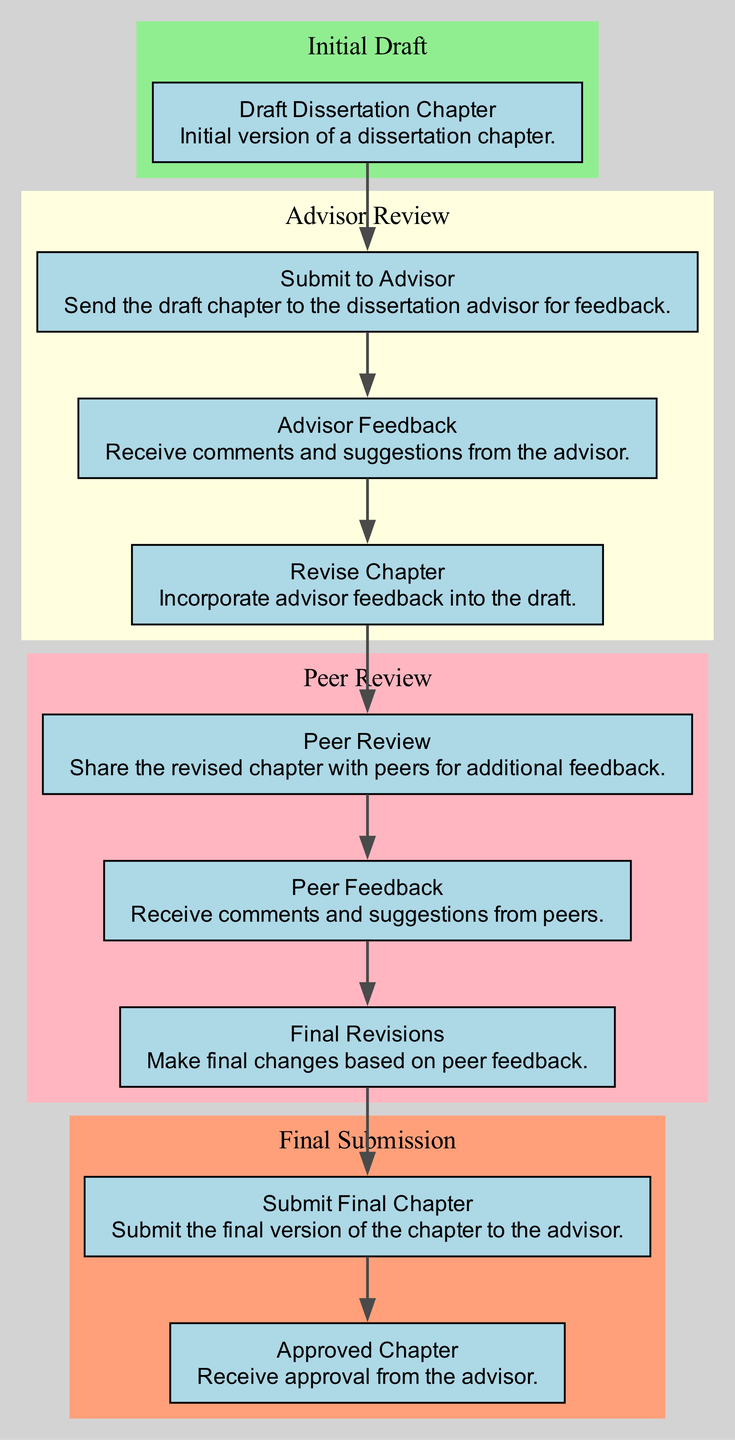What is the first step in the feedback loop? The first step in the feedback loop starts with the "Draft Dissertation Chapter", where the initial version is created.
Answer: Draft Dissertation Chapter How many sections are there in the flow chart? The flow chart is divided into four sections: Initial Draft, Advisor Review, Peer Review, and Final Submission.
Answer: Four What comes after "Submit to Advisor"? After submitting to the advisor, the next step is to receive "Advisor Feedback."
Answer: Advisor Feedback How many feedback sources are included in the process? The diagram shows two feedback sources: the advisor and peers.
Answer: Two What is the outcome after "Final Revisions"? The outcome after "Final Revisions" is to "Submit Final Chapter" to the advisor.
Answer: Submit Final Chapter Which node follows "Peer Review"? The node that follows "Peer Review" is "Peer Feedback".
Answer: Peer Feedback What actions are required after receiving "Peer Feedback"? After receiving "Peer Feedback", the necessary action is to make "Final Revisions".
Answer: Final Revisions What happens if the advisor does not approve the chapter? The feedback loop does not show an explicit path if the chapter is not approved; it implies revisions would be needed.
Answer: Revisions needed What is encapsulated within the "Peer Review" cluster? The "Peer Review" cluster encapsulates the nodes for "Peer Review," "Peer Feedback," and "Final Revisions."
Answer: Peer Review, Peer Feedback, Final Revisions Which node symbolizes the final step of the process? The final step of the process is symbolized by the node "Approved Chapter."
Answer: Approved Chapter 